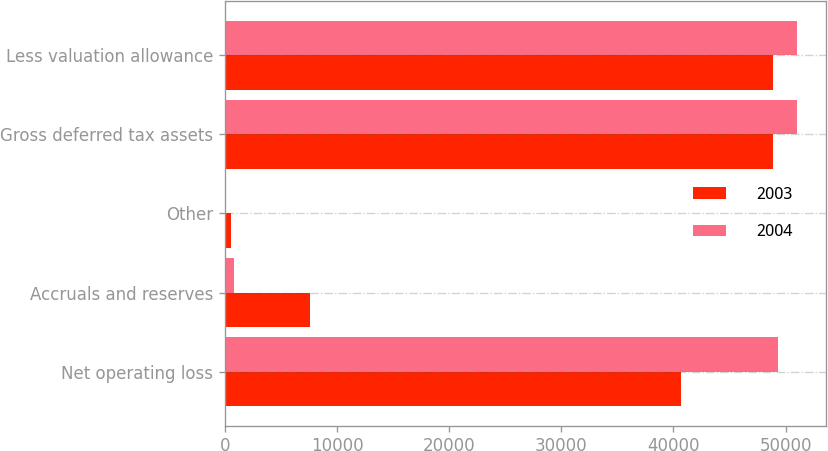<chart> <loc_0><loc_0><loc_500><loc_500><stacked_bar_chart><ecel><fcel>Net operating loss<fcel>Accruals and reserves<fcel>Other<fcel>Gross deferred tax assets<fcel>Less valuation allowance<nl><fcel>2003<fcel>40657<fcel>7602<fcel>592<fcel>48851<fcel>48851<nl><fcel>2004<fcel>49337<fcel>853<fcel>14<fcel>51047<fcel>51047<nl></chart> 